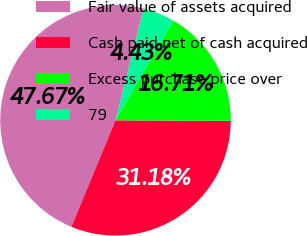Convert chart to OTSL. <chart><loc_0><loc_0><loc_500><loc_500><pie_chart><fcel>Fair value of assets acquired<fcel>Cash paid net of cash acquired<fcel>Excess purchase price over<fcel>79<nl><fcel>47.67%<fcel>31.18%<fcel>16.71%<fcel>4.43%<nl></chart> 